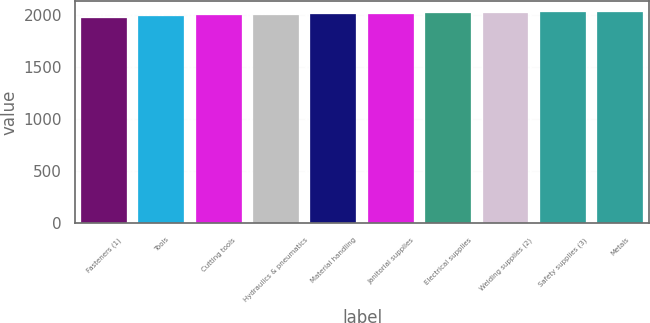Convert chart. <chart><loc_0><loc_0><loc_500><loc_500><bar_chart><fcel>Fasteners (1)<fcel>Tools<fcel>Cutting tools<fcel>Hydraulics & pneumatics<fcel>Material handling<fcel>Janitorial supplies<fcel>Electrical supplies<fcel>Welding supplies (2)<fcel>Safety supplies (3)<fcel>Metals<nl><fcel>1967<fcel>1993<fcel>1997.3<fcel>2001.6<fcel>2005.9<fcel>2010.2<fcel>2014.5<fcel>2018.8<fcel>2023.1<fcel>2027.4<nl></chart> 